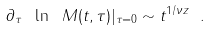<formula> <loc_0><loc_0><loc_500><loc_500>\partial _ { \tau } \ \ln \ M ( t , \tau ) | _ { \tau = 0 } \sim t ^ { 1 / \nu z } \ .</formula> 